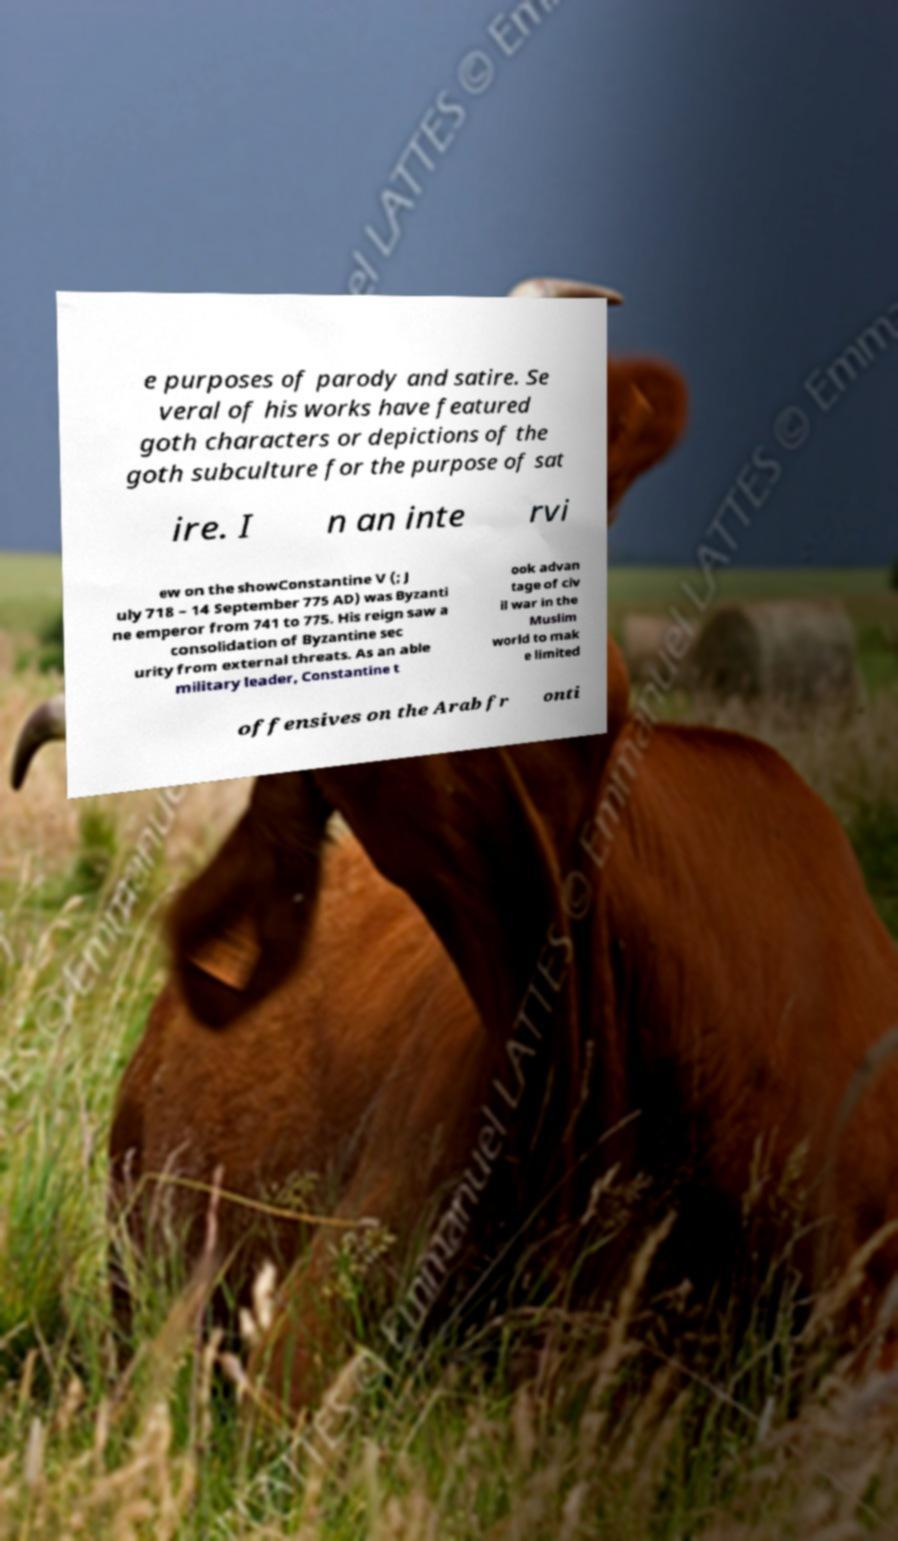What messages or text are displayed in this image? I need them in a readable, typed format. e purposes of parody and satire. Se veral of his works have featured goth characters or depictions of the goth subculture for the purpose of sat ire. I n an inte rvi ew on the showConstantine V (; J uly 718 – 14 September 775 AD) was Byzanti ne emperor from 741 to 775. His reign saw a consolidation of Byzantine sec urity from external threats. As an able military leader, Constantine t ook advan tage of civ il war in the Muslim world to mak e limited offensives on the Arab fr onti 